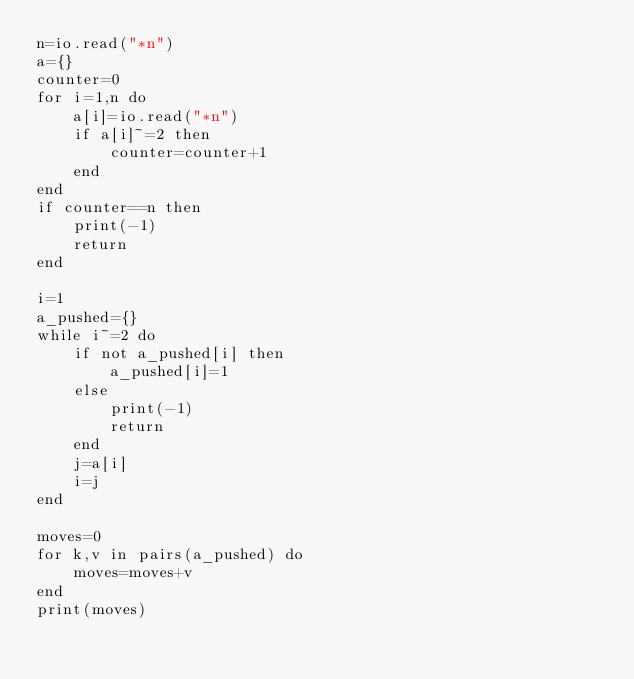<code> <loc_0><loc_0><loc_500><loc_500><_Lua_>n=io.read("*n")
a={}
counter=0
for i=1,n do
    a[i]=io.read("*n")
    if a[i]~=2 then
        counter=counter+1
    end
end
if counter==n then
    print(-1)
    return
end

i=1
a_pushed={}
while i~=2 do
    if not a_pushed[i] then
        a_pushed[i]=1
    else
        print(-1)
        return
    end
    j=a[i]
    i=j
end

moves=0
for k,v in pairs(a_pushed) do
    moves=moves+v
end
print(moves)</code> 